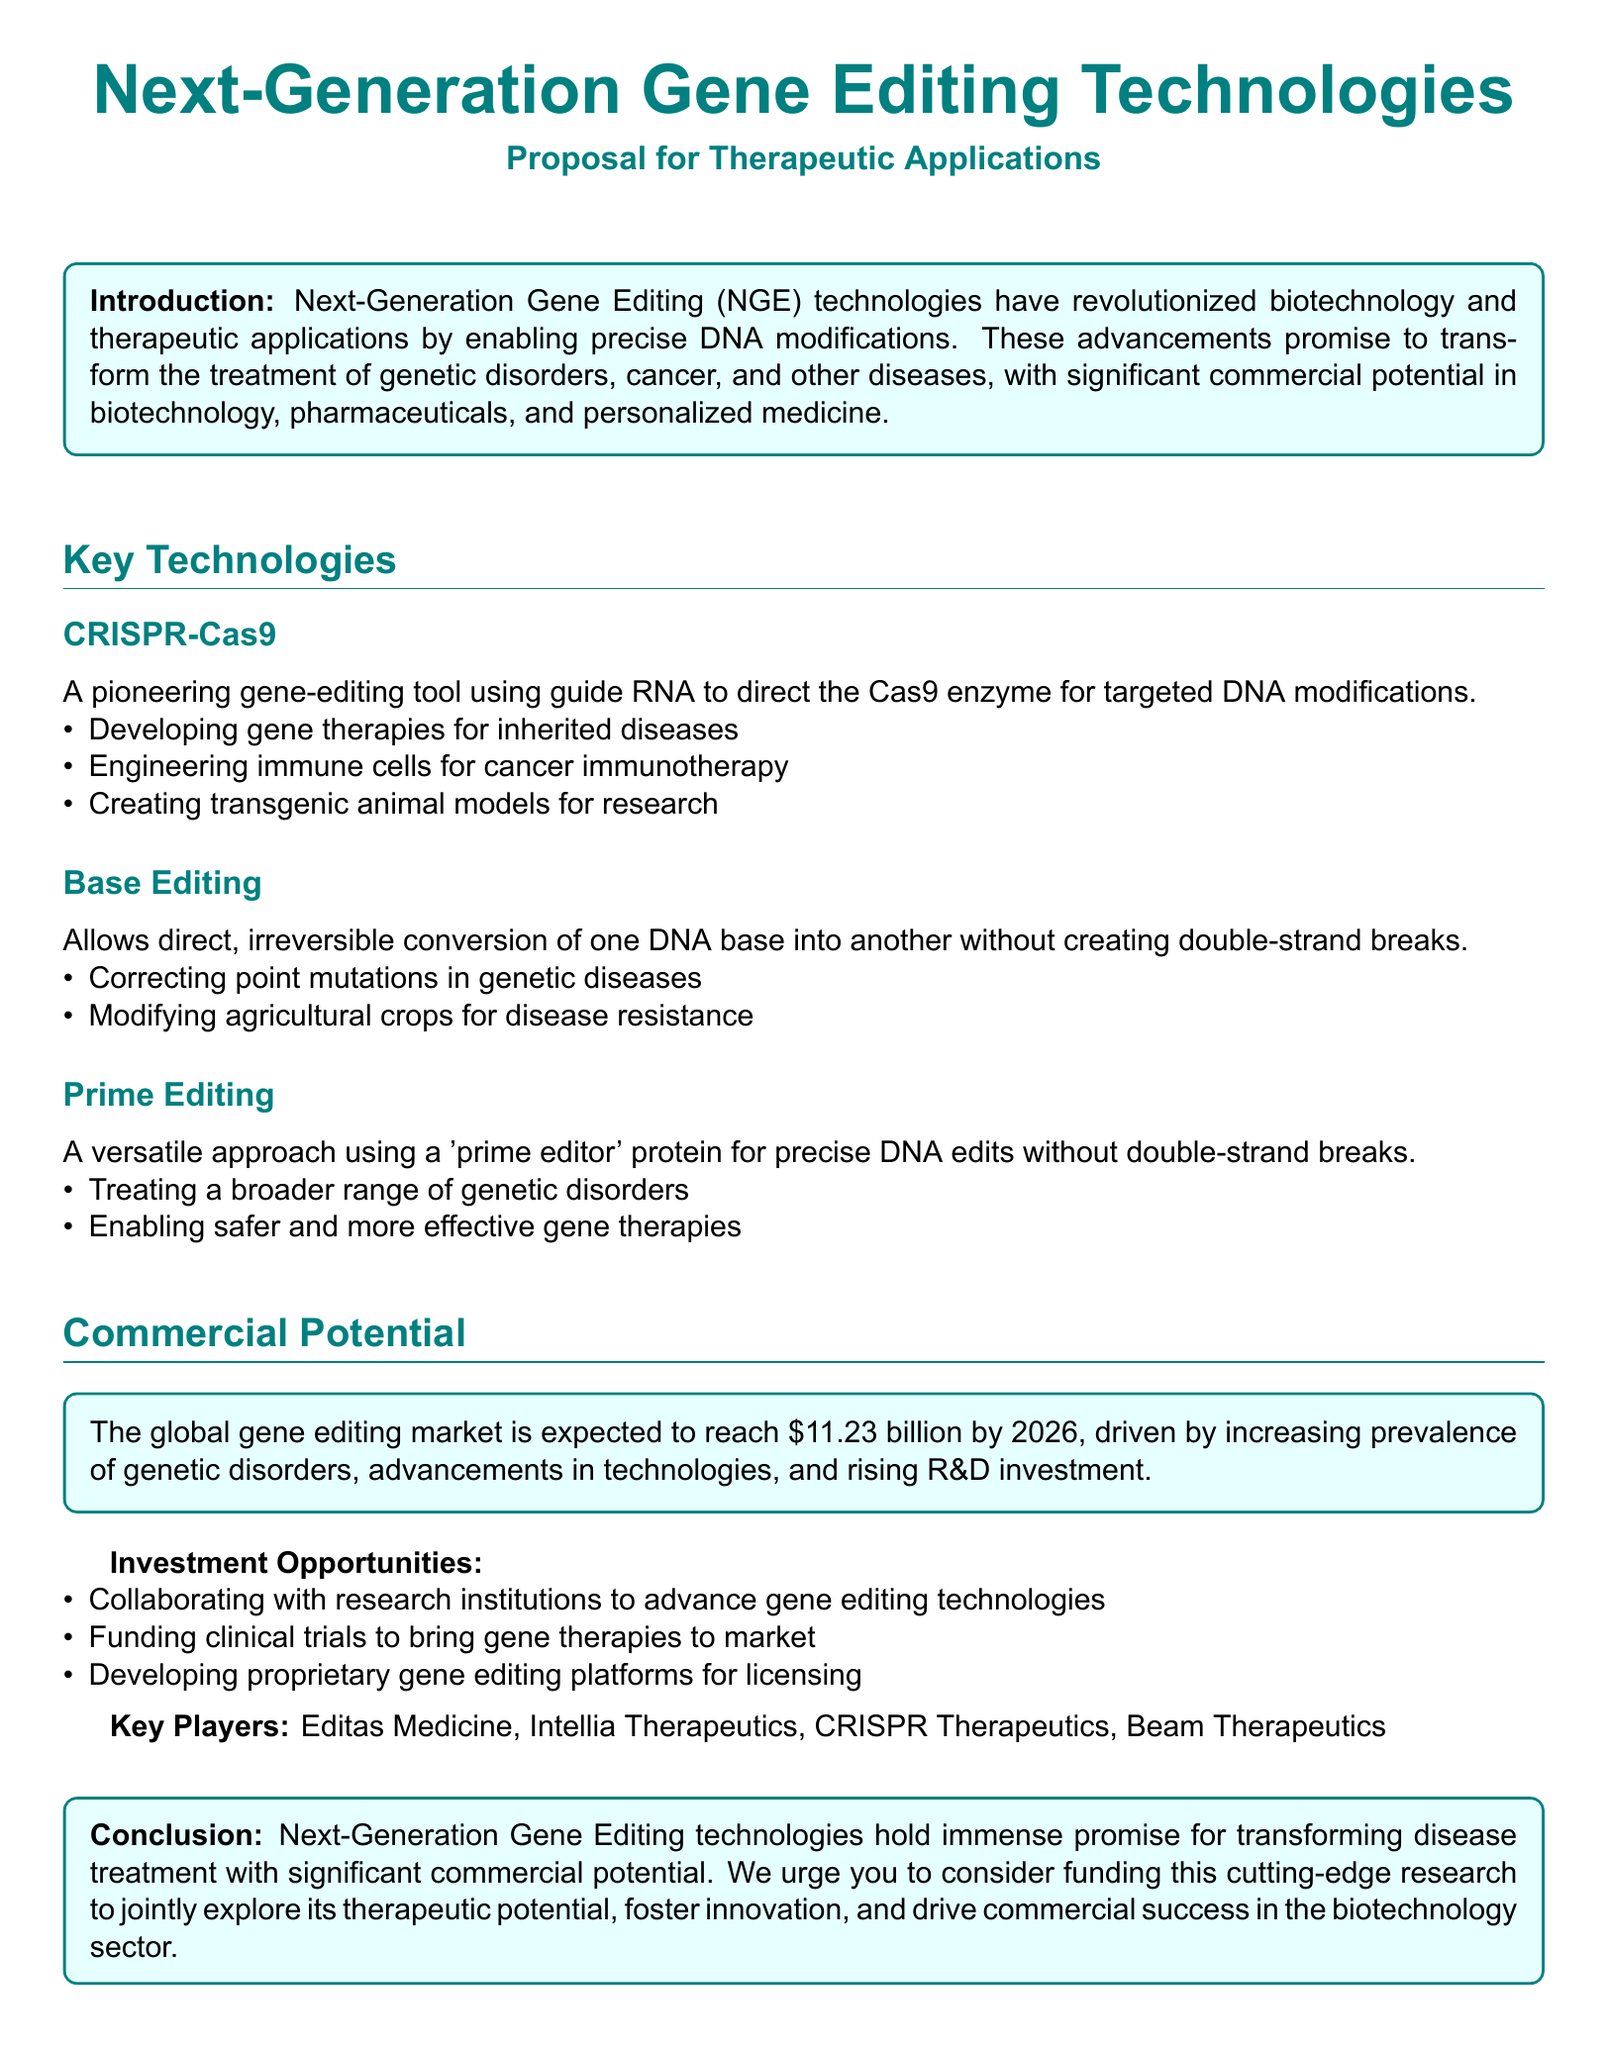What are the key technologies mentioned? The document lists key technologies under the section "Key Technologies," specifically CRISPR-Cas9, Base Editing, and Prime Editing.
Answer: CRISPR-Cas9, Base Editing, Prime Editing What is the expected global gene editing market value by 2026? The document states that the global gene editing market is expected to reach $11.23 billion by 2026.
Answer: $11.23 billion What is one main application of CRISPR-Cas9? Under the sub-section for CRISPR-Cas9, one main application mentioned is developing gene therapies for inherited diseases.
Answer: Developing gene therapies for inherited diseases What novel approach does Prime Editing use? The document describes Prime Editing as using a 'prime editor' protein for precise DNA edits without double-strand breaks.
Answer: 'Prime editor' protein What type of investment opportunities does the proposal suggest? The document outlines various investment opportunities, including collaborating with research institutions to advance gene editing technologies.
Answer: Collaborating with research institutions How many key players are listed in the document? The document mentions four key players in the gene editing market.
Answer: Four Which technology allows direct conversion of one DNA base into another? Base Editing is the technology mentioned that allows for this direct conversion without creating double-strand breaks.
Answer: Base Editing What was the focus of the proposal's conclusion? The conclusion urges consideration for funding cutting-edge research in next-generation gene editing technologies to explore therapeutic potential.
Answer: Funding cutting-edge research 